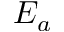<formula> <loc_0><loc_0><loc_500><loc_500>E _ { a }</formula> 